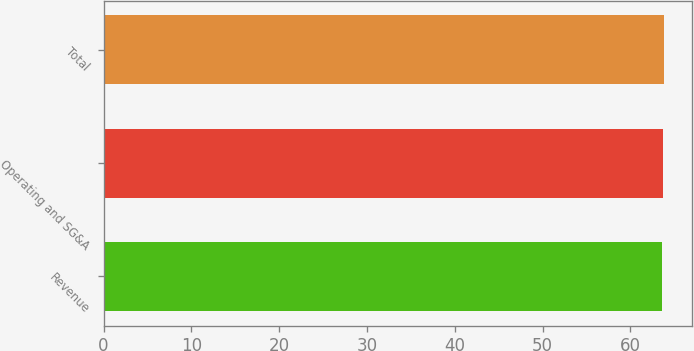Convert chart to OTSL. <chart><loc_0><loc_0><loc_500><loc_500><bar_chart><fcel>Revenue<fcel>Operating and SG&A<fcel>Total<nl><fcel>63.6<fcel>63.7<fcel>63.8<nl></chart> 